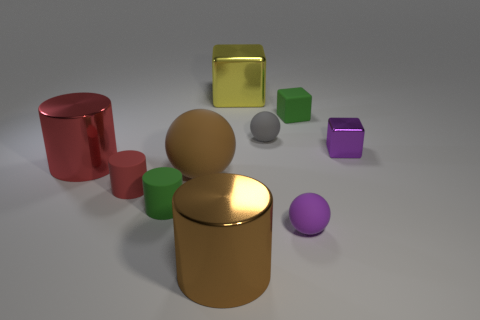What number of other objects are the same shape as the big brown shiny thing?
Give a very brief answer. 3. What number of purple rubber things are behind the big yellow thing?
Make the answer very short. 0. There is a green object on the left side of the large yellow block; is it the same size as the shiny thing that is in front of the big red cylinder?
Your answer should be very brief. No. What number of other things are there of the same size as the gray ball?
Offer a terse response. 5. What material is the large cylinder to the left of the metallic cylinder that is in front of the large shiny object that is left of the tiny red thing?
Provide a short and direct response. Metal. Does the brown metallic thing have the same size as the purple object in front of the red shiny cylinder?
Your response must be concise. No. There is a thing that is behind the large rubber ball and left of the big brown shiny cylinder; what size is it?
Provide a short and direct response. Large. Are there any rubber things that have the same color as the big metal block?
Make the answer very short. No. There is a rubber object on the left side of the green object on the left side of the brown sphere; what is its color?
Your answer should be very brief. Red. Are there fewer small gray balls behind the red shiny cylinder than tiny green cubes behind the green block?
Keep it short and to the point. No. 